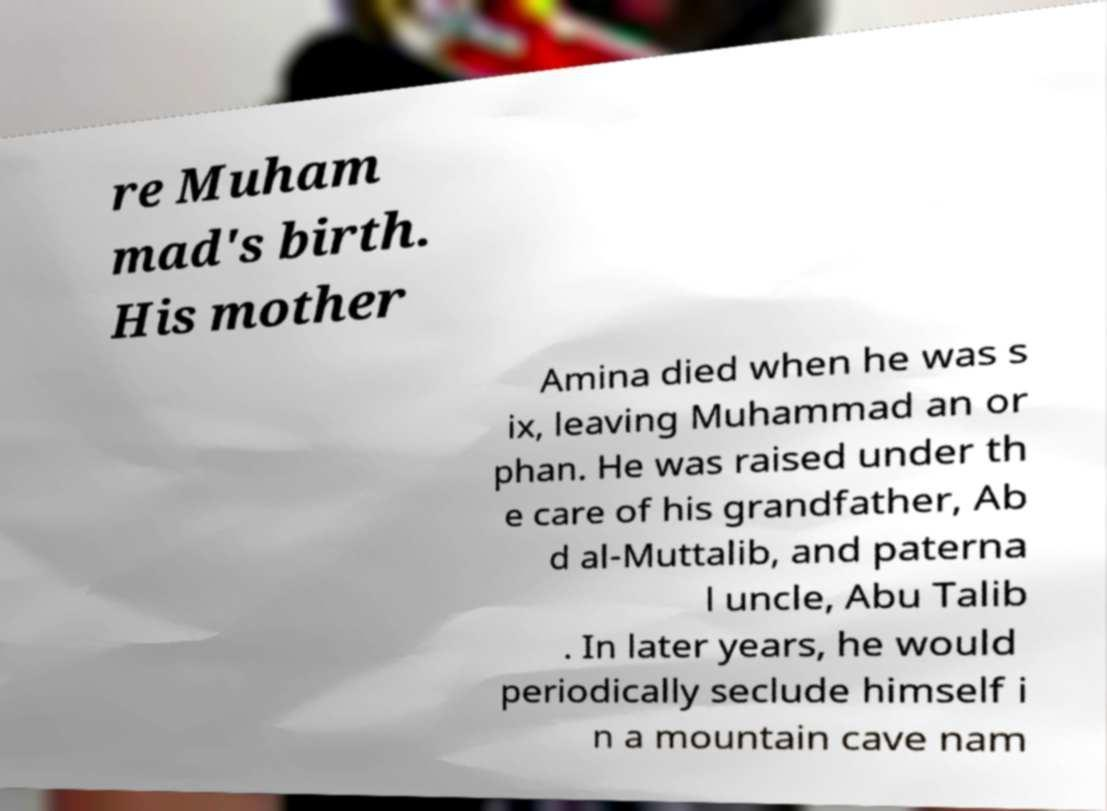There's text embedded in this image that I need extracted. Can you transcribe it verbatim? re Muham mad's birth. His mother Amina died when he was s ix, leaving Muhammad an or phan. He was raised under th e care of his grandfather, Ab d al-Muttalib, and paterna l uncle, Abu Talib . In later years, he would periodically seclude himself i n a mountain cave nam 